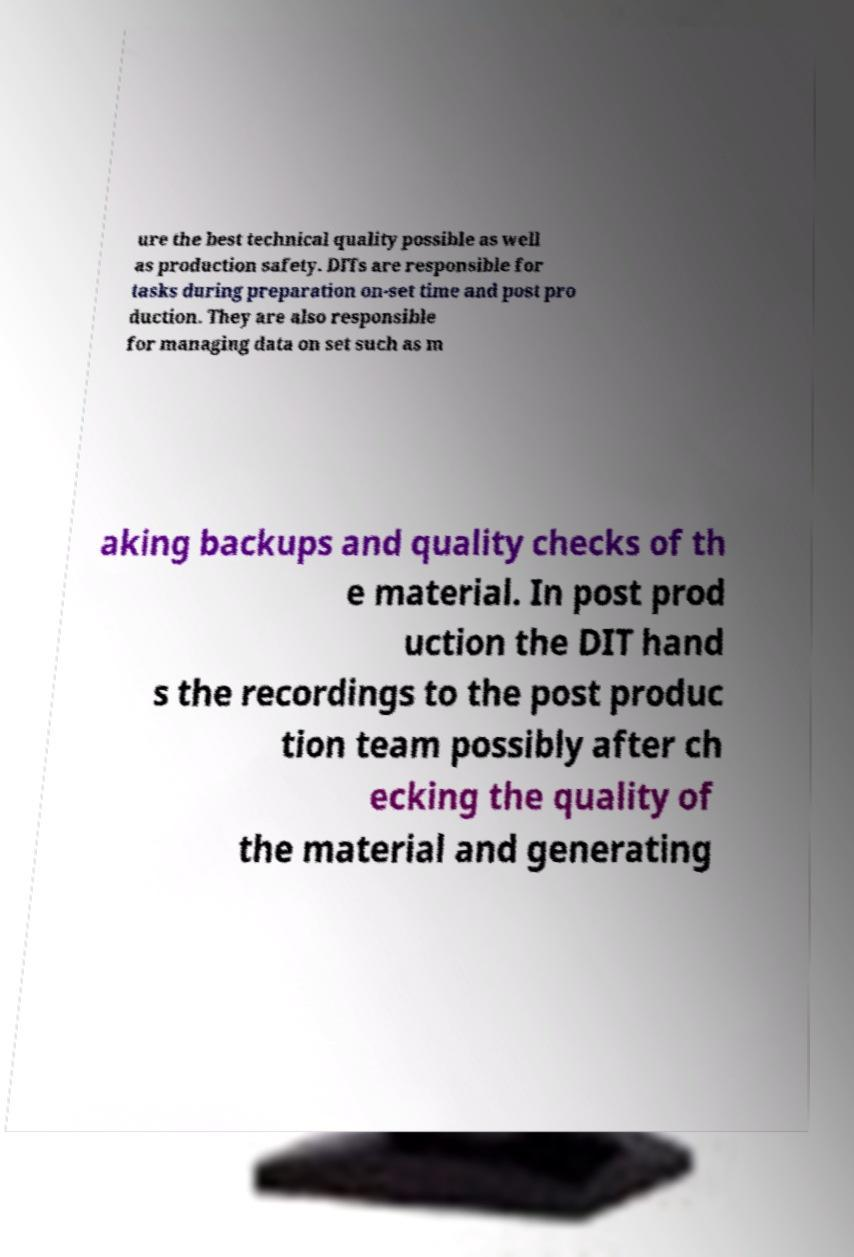Could you assist in decoding the text presented in this image and type it out clearly? ure the best technical quality possible as well as production safety. DITs are responsible for tasks during preparation on-set time and post pro duction. They are also responsible for managing data on set such as m aking backups and quality checks of th e material. In post prod uction the DIT hand s the recordings to the post produc tion team possibly after ch ecking the quality of the material and generating 